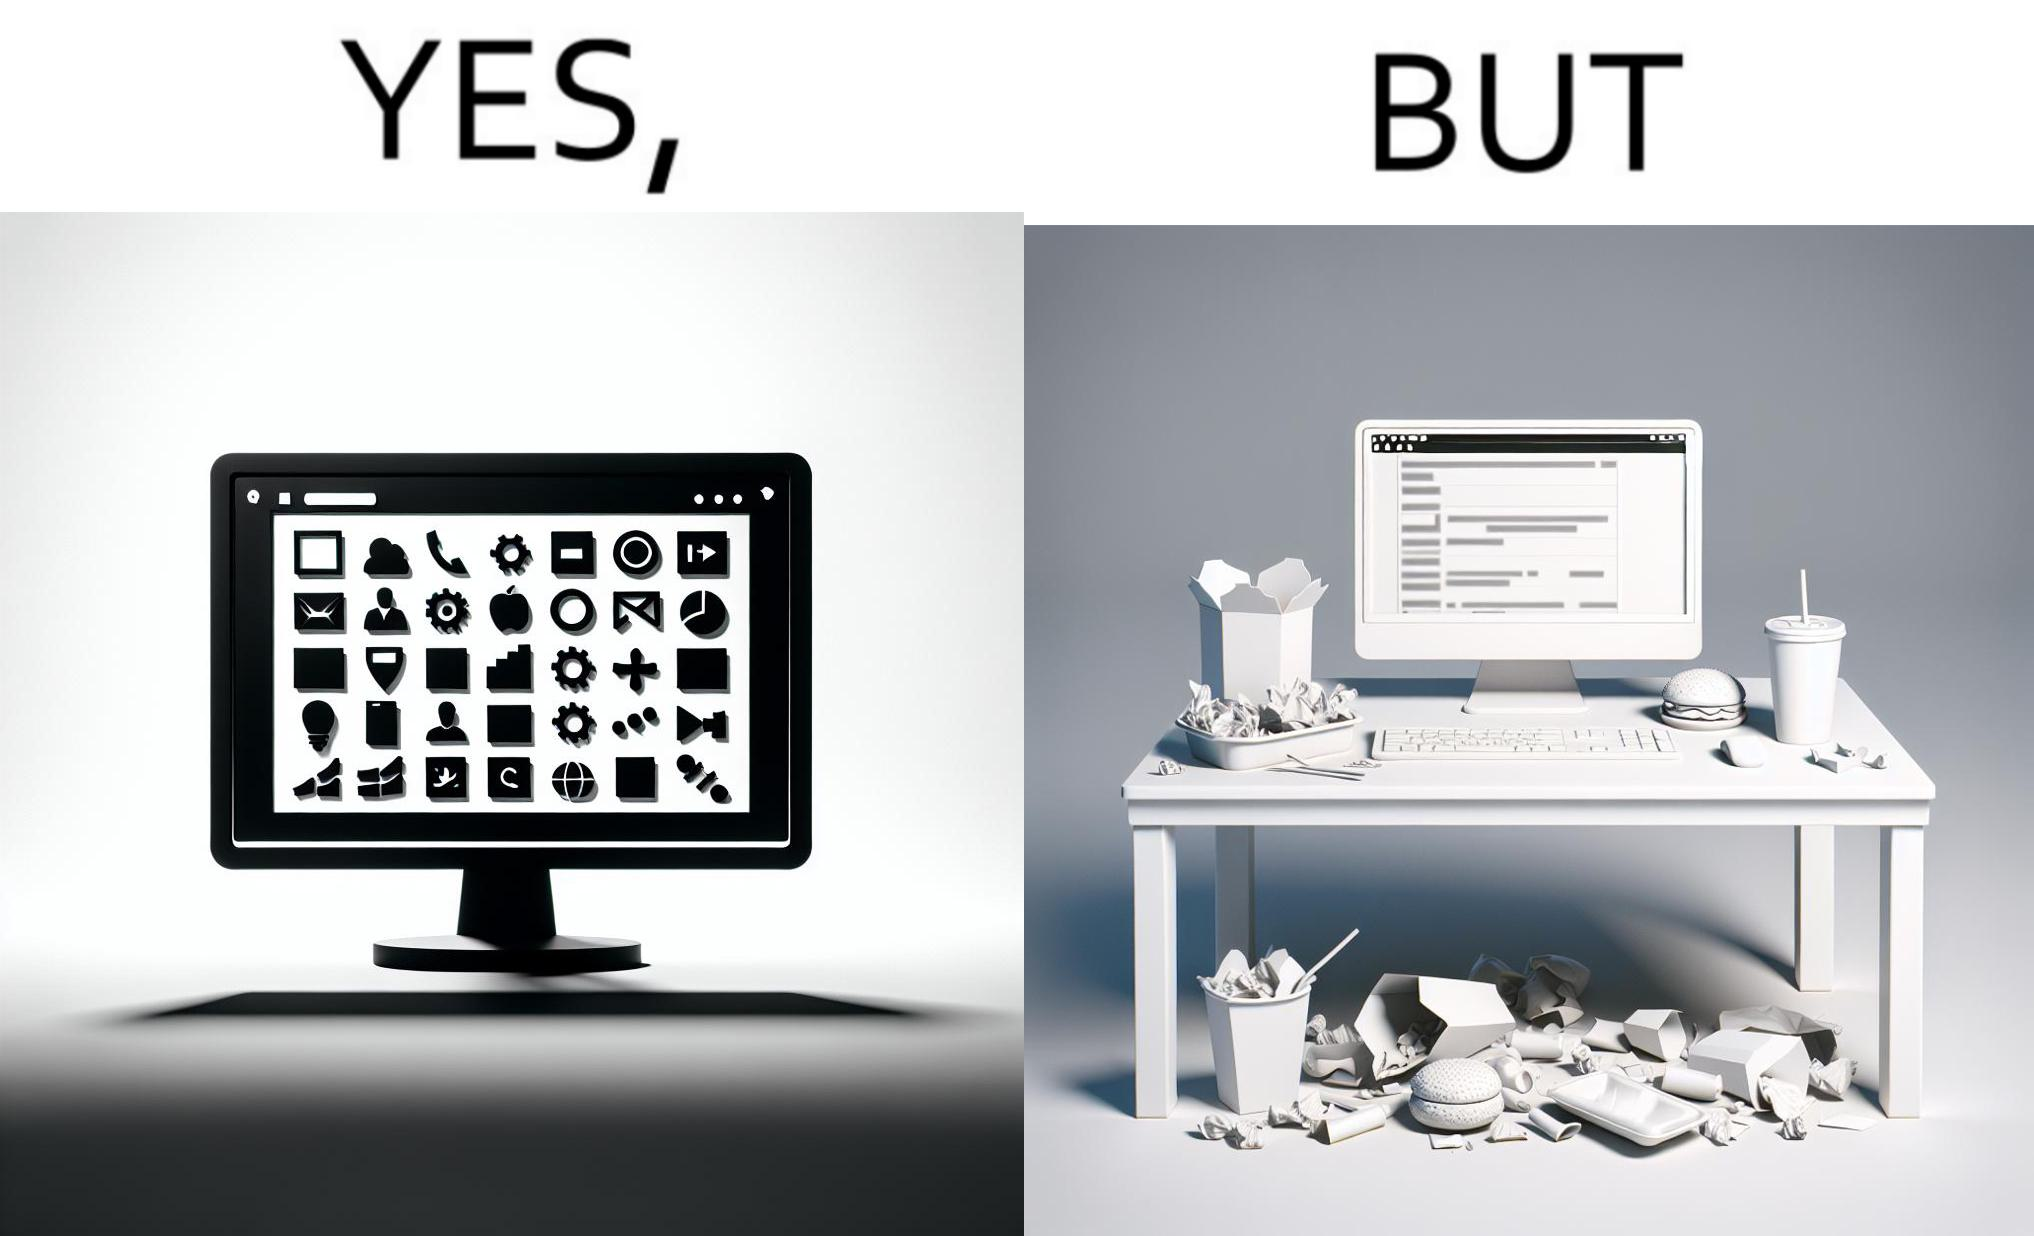Explain the humor or irony in this image. The image is ironical, as the folder icons on the desktop screen are very neatly arranged, while the person using the computer has littered the table with used food packets, dirty plates, and wrappers. 